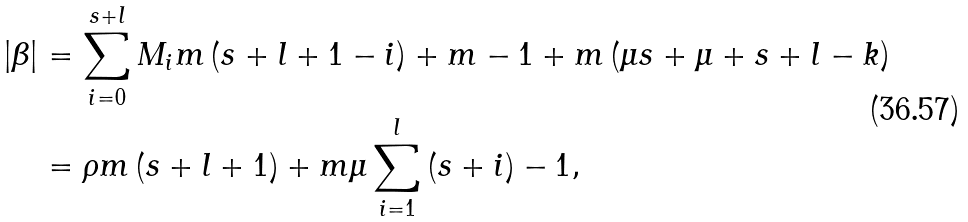<formula> <loc_0><loc_0><loc_500><loc_500>\left | \beta \right | & = \sum _ { i = 0 } ^ { s + l } M _ { i } m \left ( s + l + 1 - i \right ) + m - 1 + m \left ( \mu s + \mu + s + l - k \right ) \\ & = \rho m \left ( s + l + 1 \right ) + m \mu \sum _ { i = 1 } ^ { l } \left ( s + i \right ) - 1 ,</formula> 